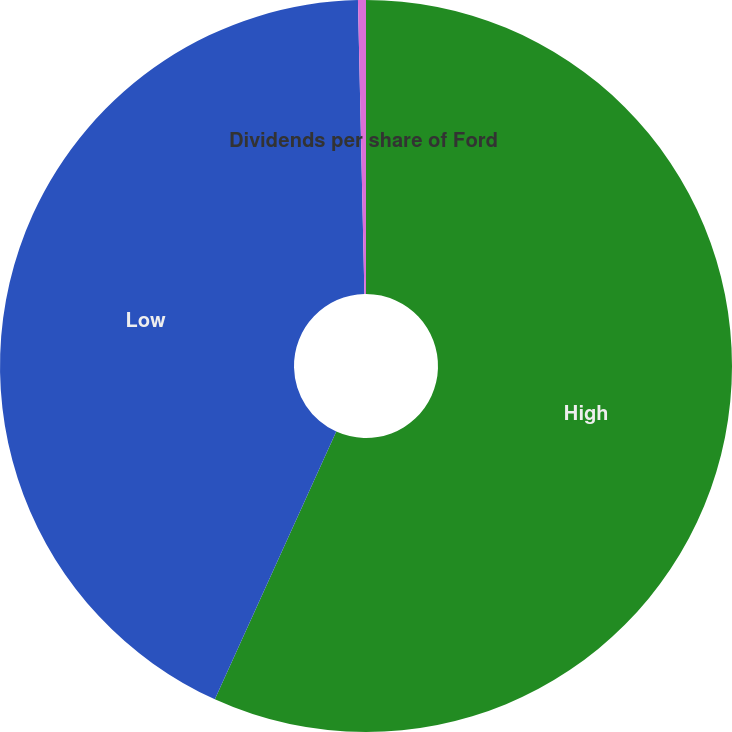Convert chart. <chart><loc_0><loc_0><loc_500><loc_500><pie_chart><fcel>High<fcel>Low<fcel>Dividends per share of Ford<nl><fcel>56.77%<fcel>42.87%<fcel>0.35%<nl></chart> 